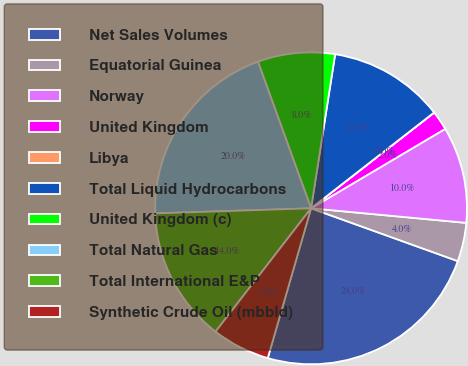Convert chart to OTSL. <chart><loc_0><loc_0><loc_500><loc_500><pie_chart><fcel>Net Sales Volumes<fcel>Equatorial Guinea<fcel>Norway<fcel>United Kingdom<fcel>Libya<fcel>Total Liquid Hydrocarbons<fcel>United Kingdom (c)<fcel>Total Natural Gas<fcel>Total International E&P<fcel>Synthetic Crude Oil (mbbld)<nl><fcel>23.98%<fcel>4.01%<fcel>10.0%<fcel>2.01%<fcel>0.01%<fcel>12.0%<fcel>8.0%<fcel>19.99%<fcel>13.99%<fcel>6.01%<nl></chart> 